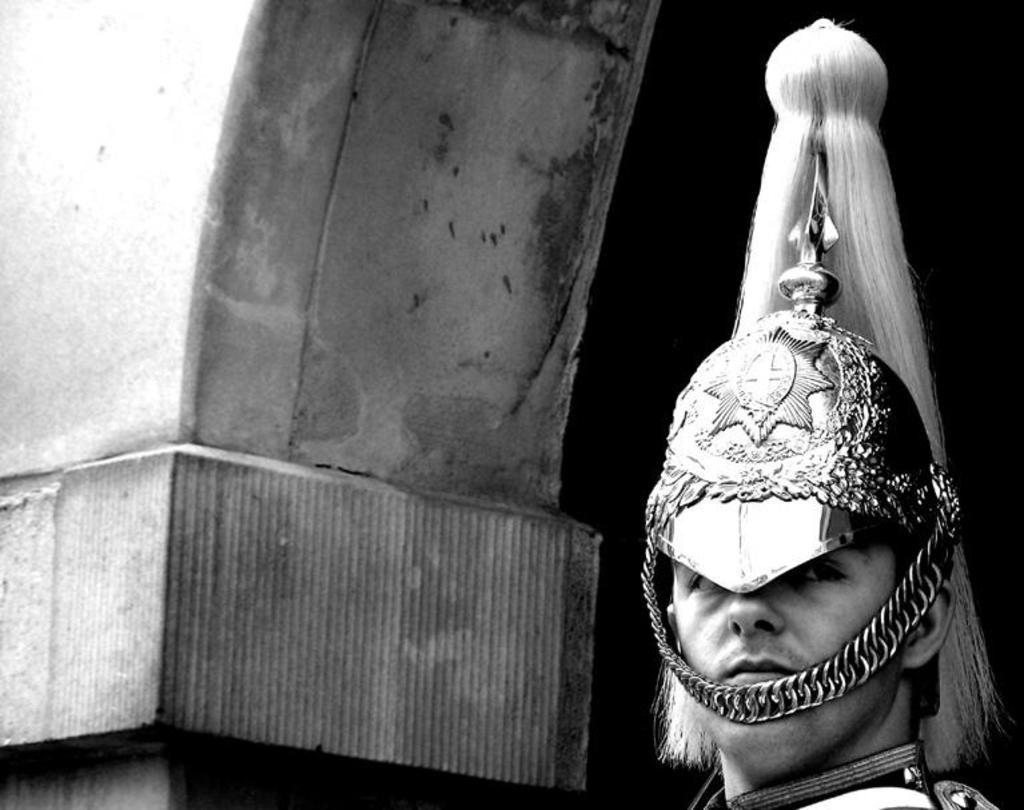How would you summarize this image in a sentence or two? In this black and white image there is a person wearing a crown on his head. On the left side of the image there is a wall. 